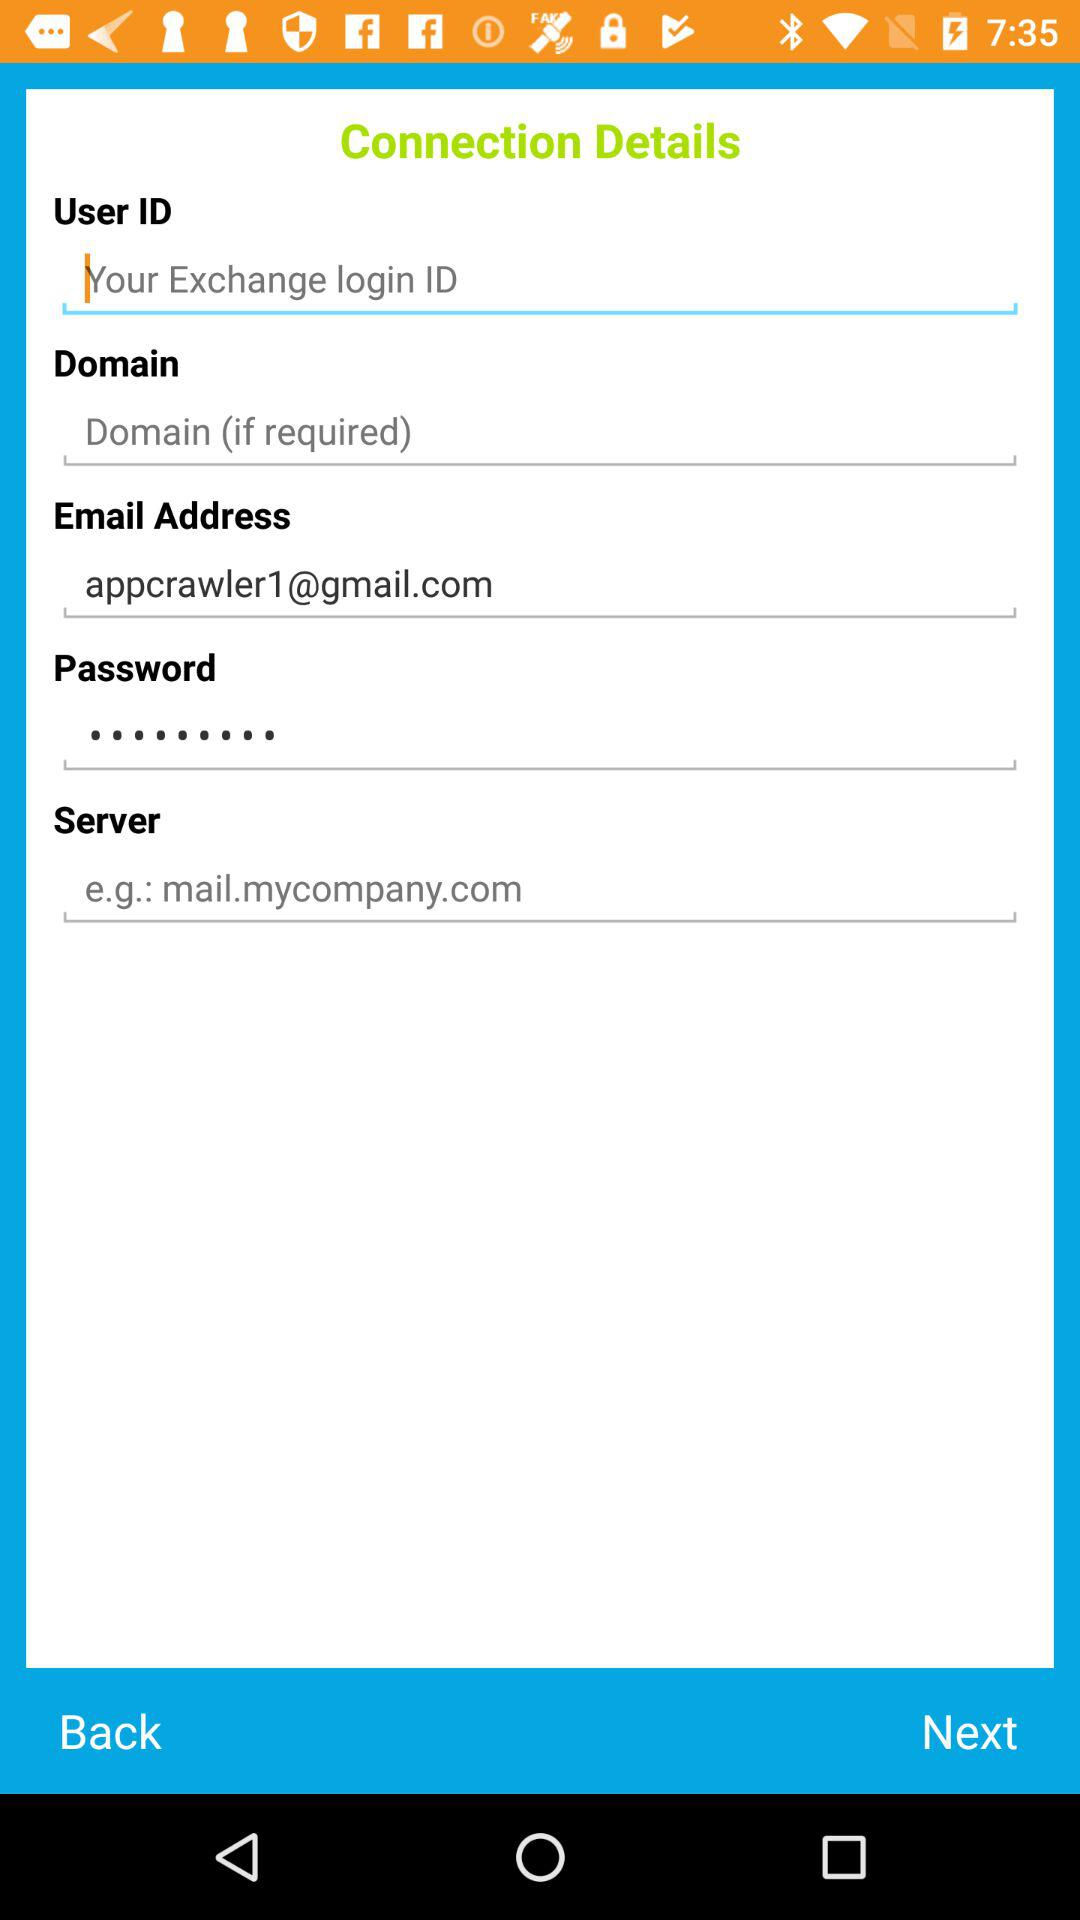What is the email address? The email address is appcrawler1@gmail.com. 